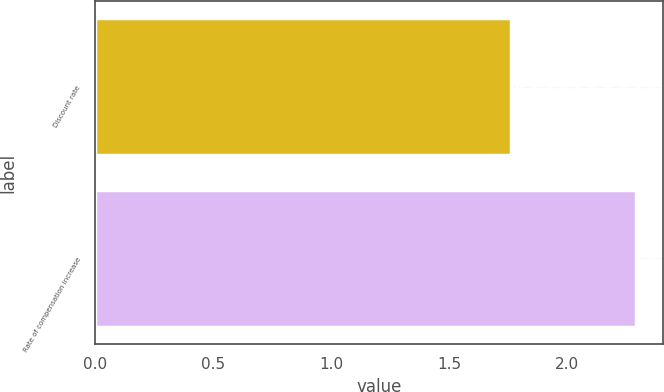Convert chart. <chart><loc_0><loc_0><loc_500><loc_500><bar_chart><fcel>Discount rate<fcel>Rate of compensation increase<nl><fcel>1.76<fcel>2.29<nl></chart> 